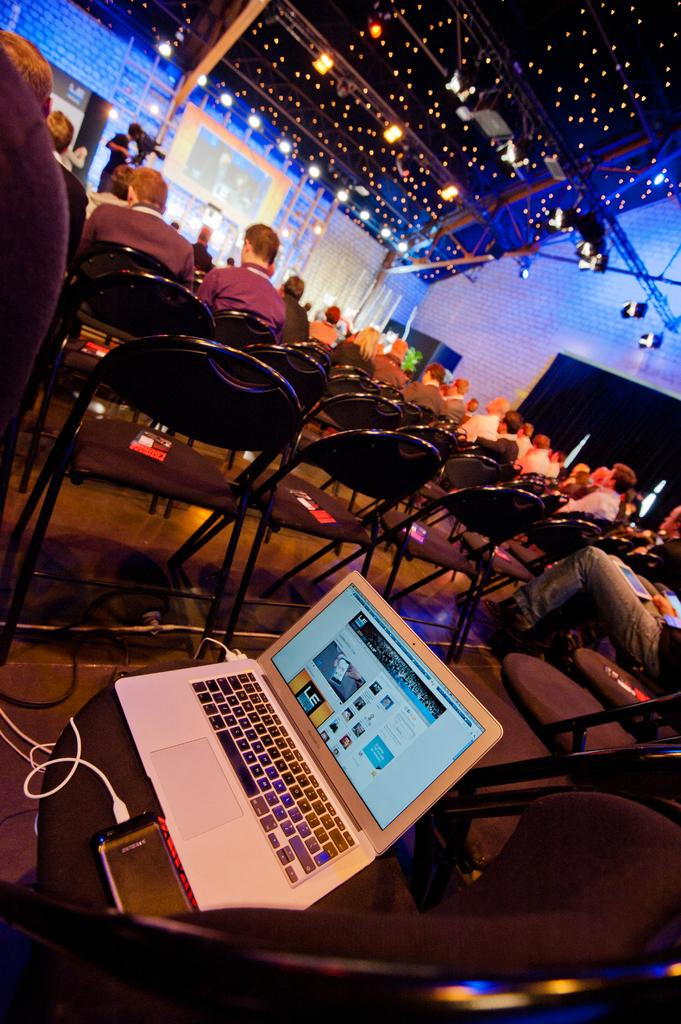What are the people in the image doing? The people in the image are sitting in chairs. What object is placed on a chair in the image? There is a laptop on a chair in the image. What can be seen on the roof in the image? Poles and lights are visible on the roof in the image. Where is the sofa located in the image? There is no sofa present in the image. What type of flower can be seen growing on the roof in the image? There are no flowers visible in the image, only poles and lights on the roof. 